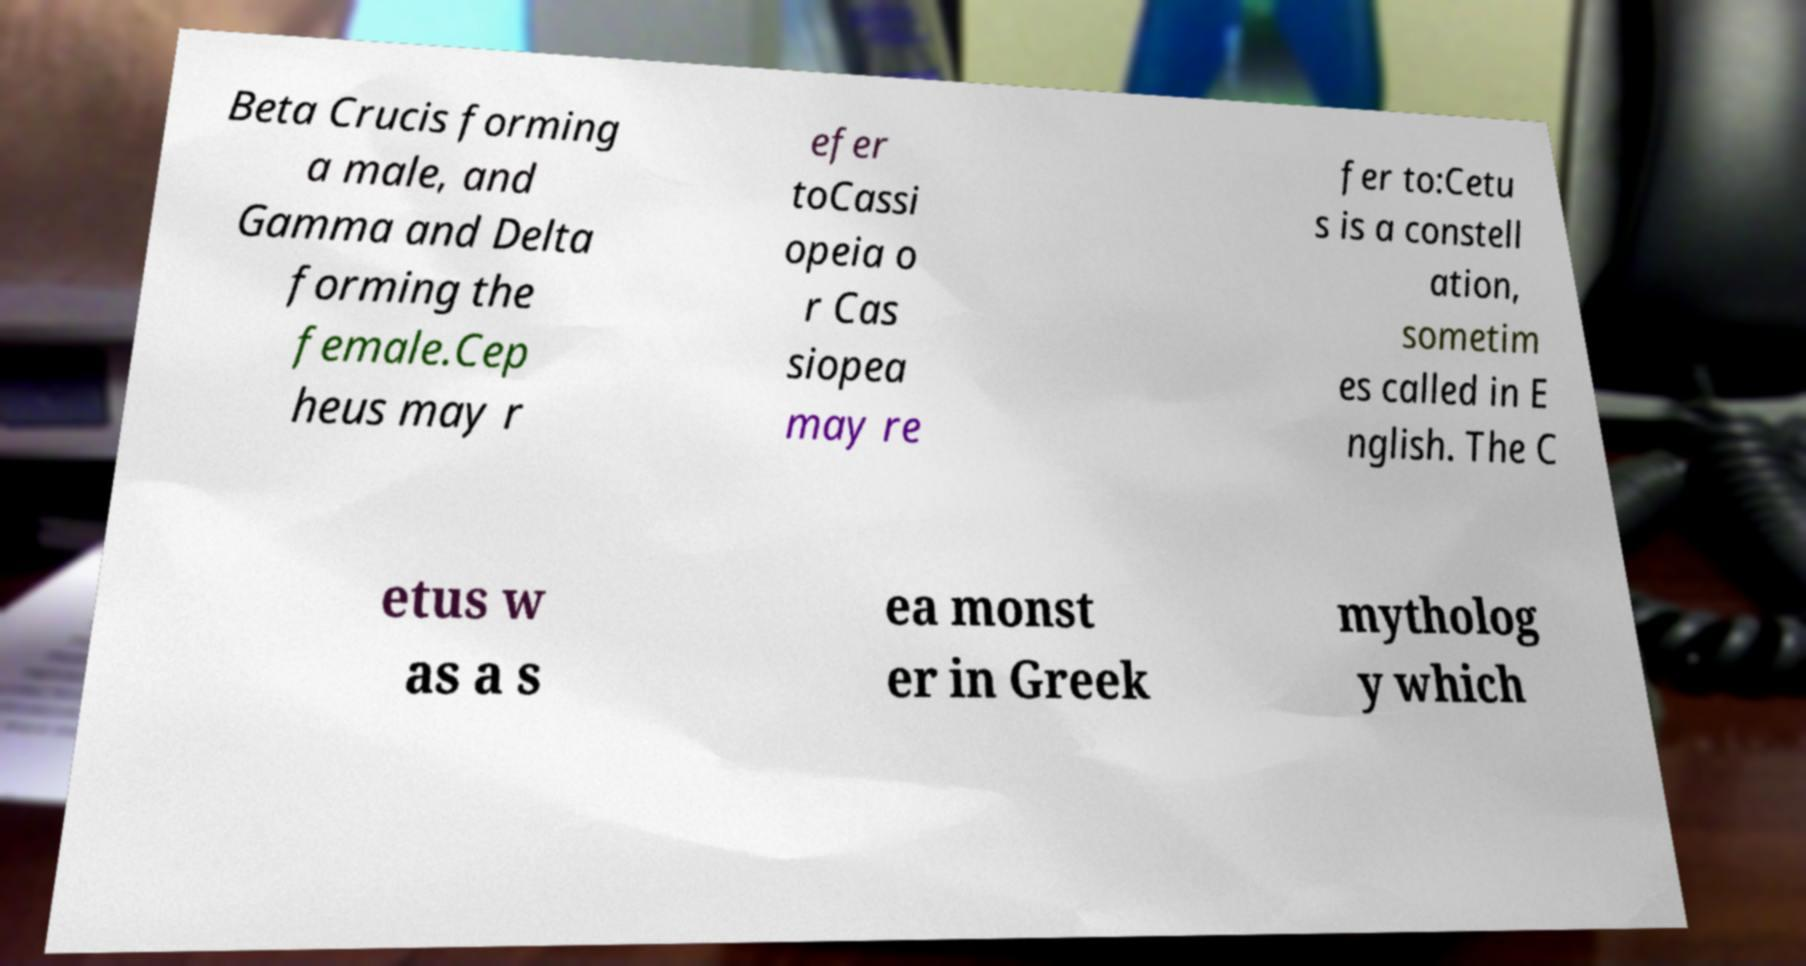Could you assist in decoding the text presented in this image and type it out clearly? Beta Crucis forming a male, and Gamma and Delta forming the female.Cep heus may r efer toCassi opeia o r Cas siopea may re fer to:Cetu s is a constell ation, sometim es called in E nglish. The C etus w as a s ea monst er in Greek mytholog y which 